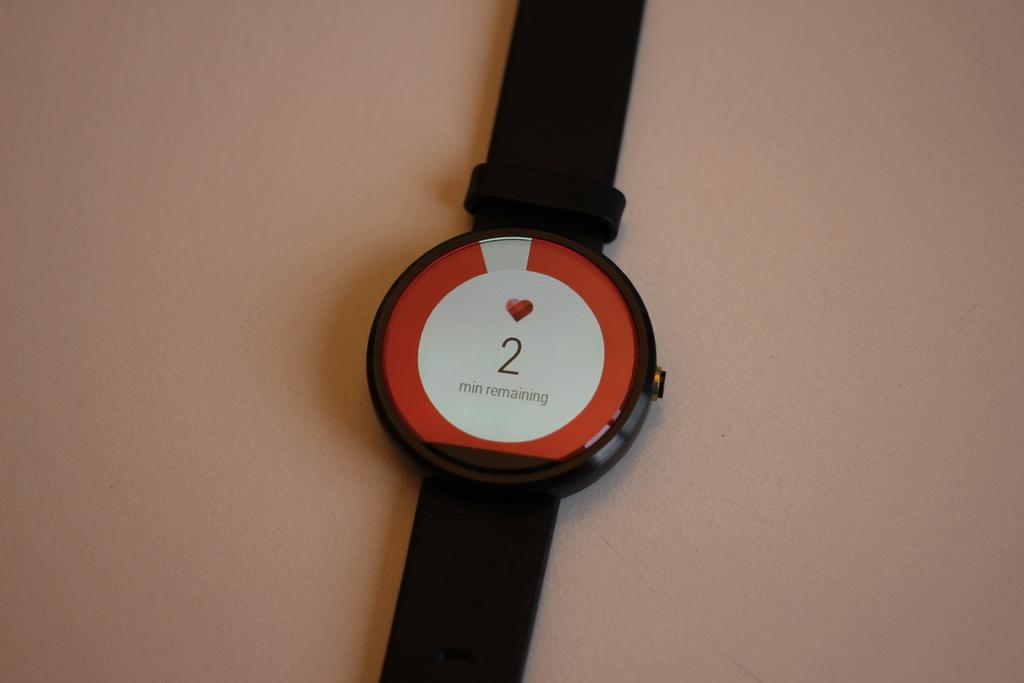<image>
Describe the image concisely. A watch that says on it 2 minutes are remaining. 